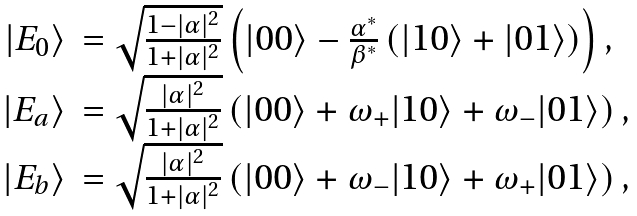<formula> <loc_0><loc_0><loc_500><loc_500>\begin{array} { r l } | E _ { 0 } \rangle & = \sqrt { \frac { 1 - | \alpha | ^ { 2 } } { 1 + | \alpha | ^ { 2 } } } \left ( | 0 0 \rangle - \frac { \alpha ^ { * } } { \beta ^ { * } } \left ( | 1 0 \rangle + | 0 1 \rangle \right ) \right ) , \\ | E _ { a } \rangle & = \sqrt { \frac { | \alpha | ^ { 2 } } { 1 + | \alpha | ^ { 2 } } } \left ( | 0 0 \rangle + \omega _ { + } | 1 0 \rangle + \omega _ { - } | 0 1 \rangle \right ) , \\ | E _ { b } \rangle & = \sqrt { \frac { | \alpha | ^ { 2 } } { 1 + | \alpha | ^ { 2 } } } \left ( | 0 0 \rangle + \omega _ { - } | 1 0 \rangle + \omega _ { + } | 0 1 \rangle \right ) , \end{array}</formula> 